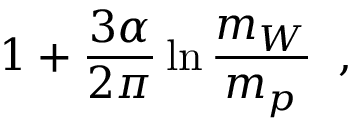Convert formula to latex. <formula><loc_0><loc_0><loc_500><loc_500>1 + \frac { 3 \alpha } { 2 \pi } \ln \frac { m _ { W } } { m _ { p } } \, ,</formula> 